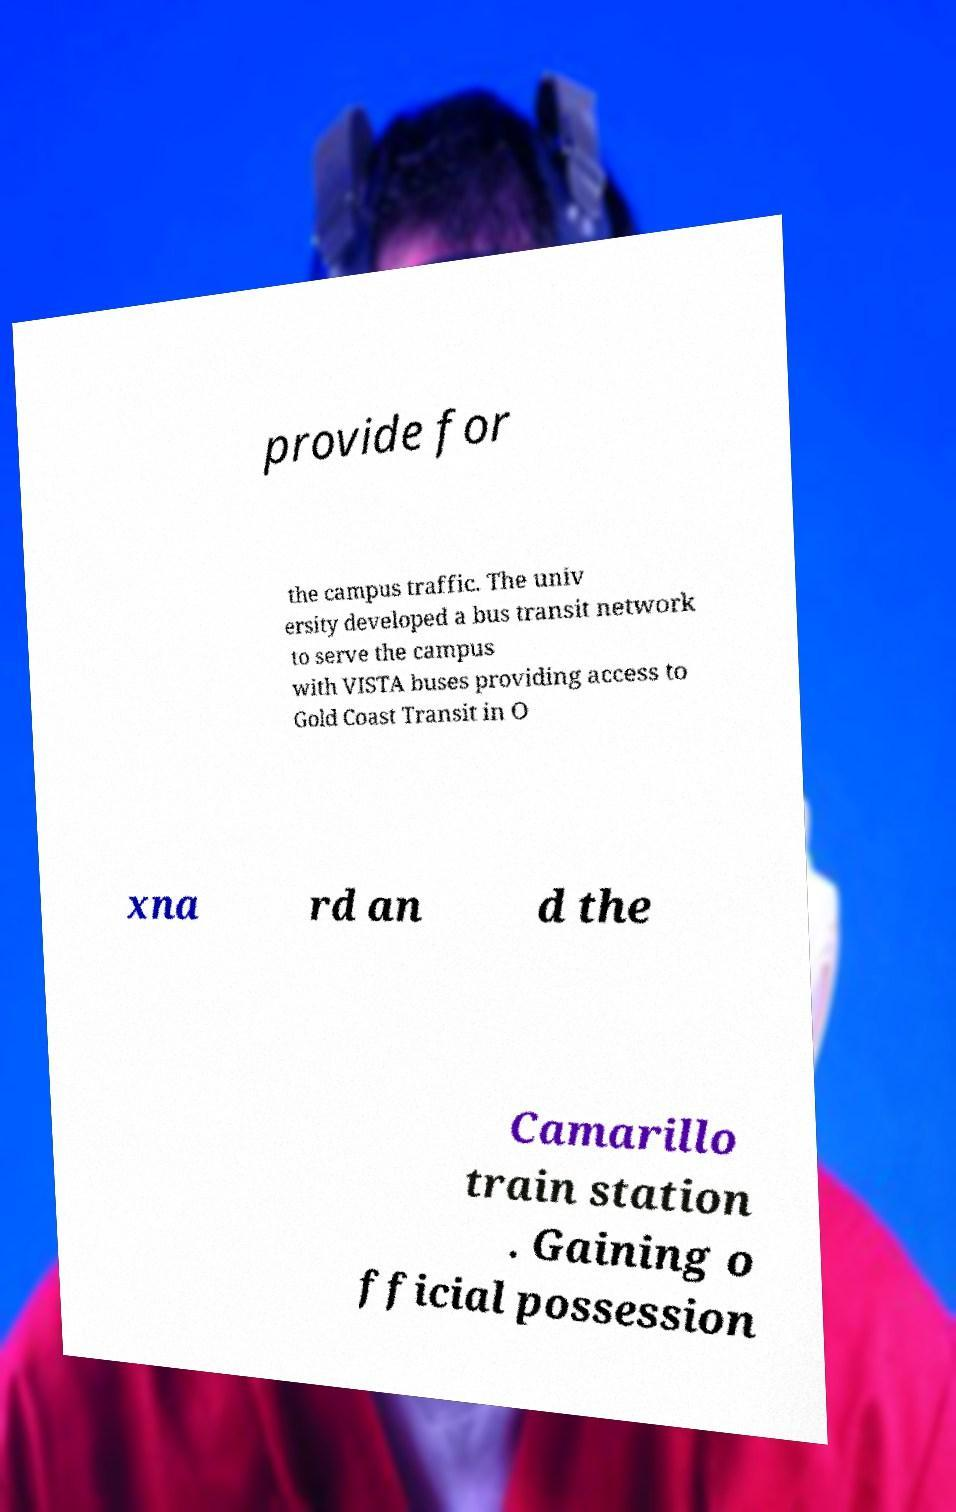For documentation purposes, I need the text within this image transcribed. Could you provide that? provide for the campus traffic. The univ ersity developed a bus transit network to serve the campus with VISTA buses providing access to Gold Coast Transit in O xna rd an d the Camarillo train station . Gaining o fficial possession 